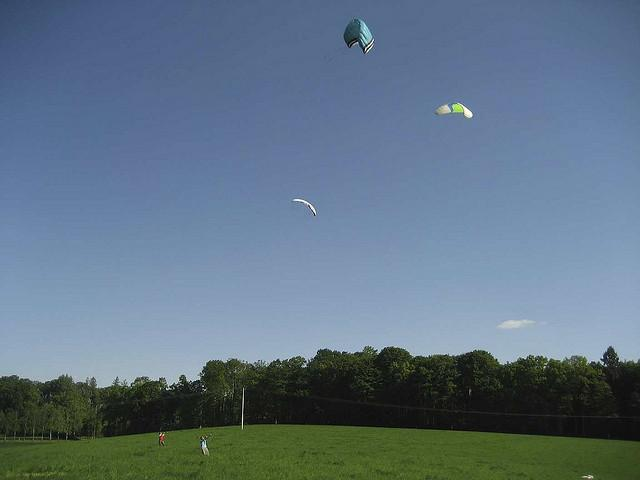The flying objects are made of what material? Please explain your reasoning. polyester. They are made out of polyester. 